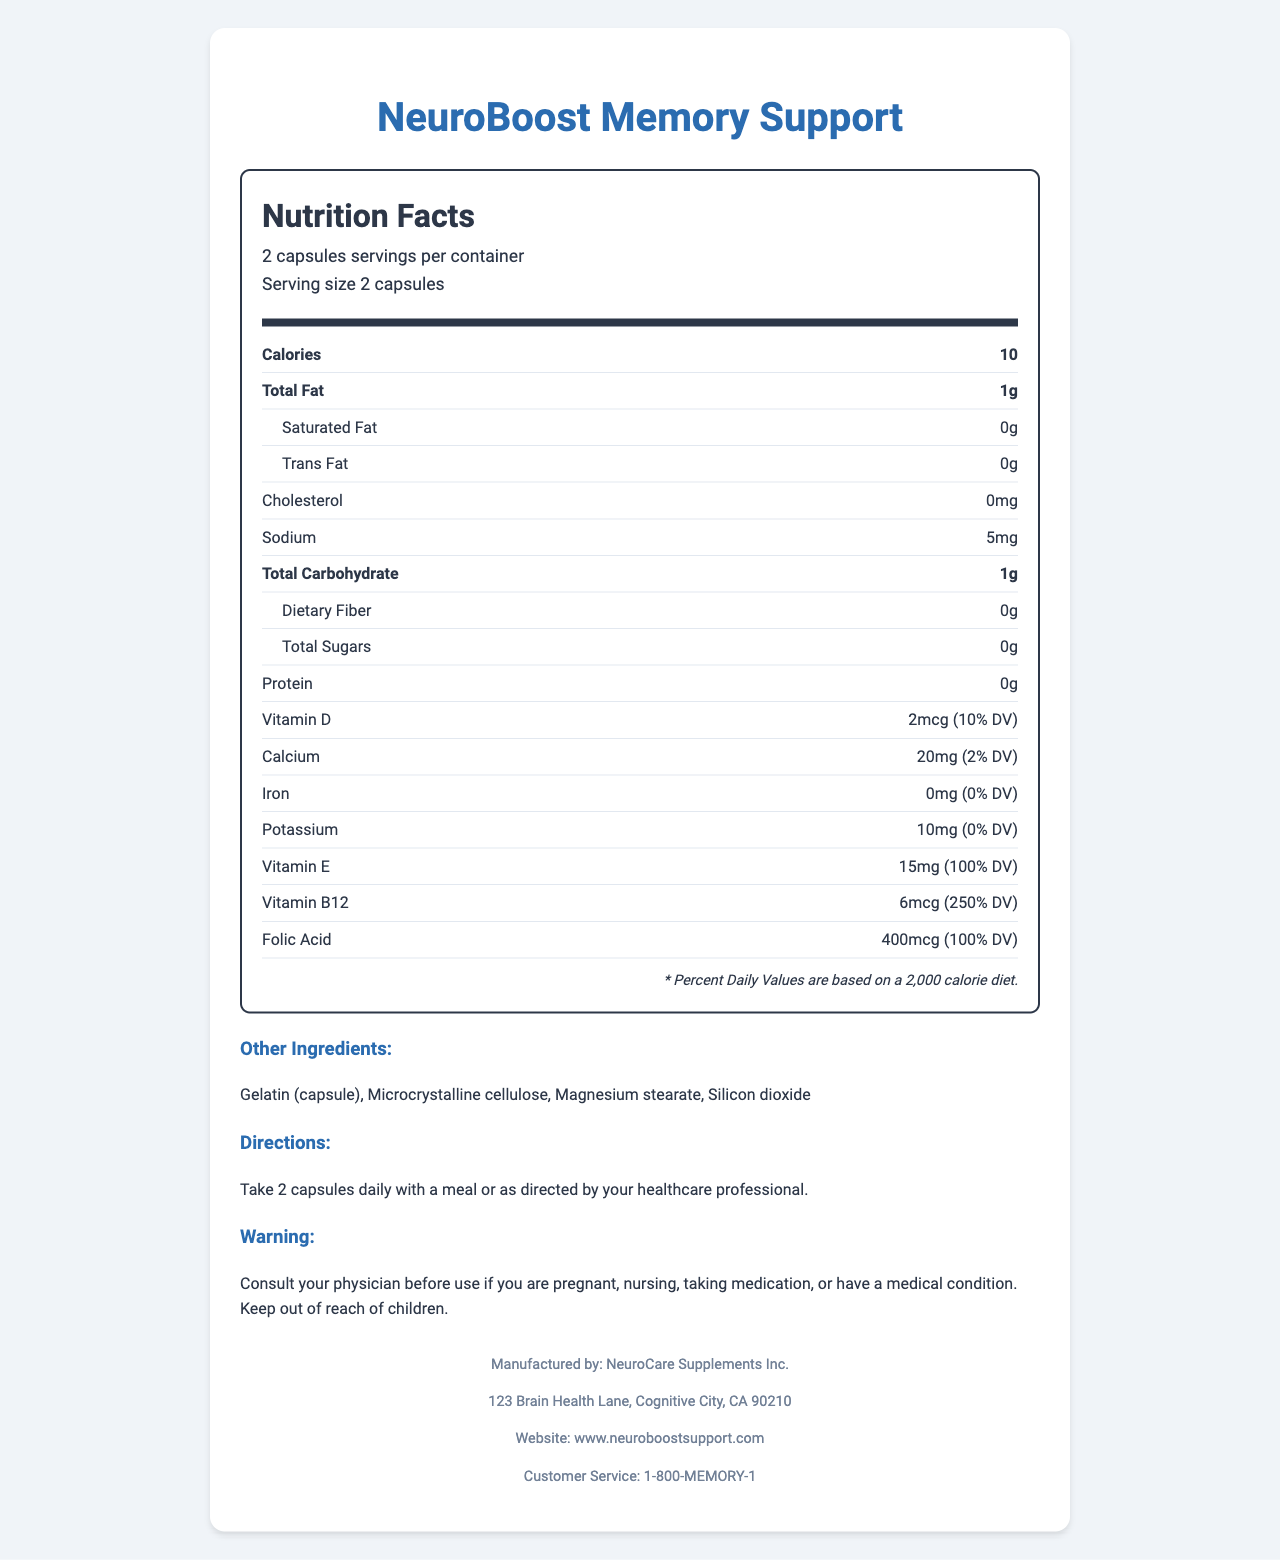what is the product's serving size? The serving size is stated at the top of the nutrition facts: "Serving size 2 capsules."
Answer: 2 capsules how many servings per container are there? The document specifies that there are 30 servings per container.
Answer: 30 what is the total amount of omega-3 fatty acids per serving? The document lists that each serving contains 1000mg of omega-3 fatty acids.
Answer: 1000mg which vitamin has the highest daily value percentage? The daily value for Vitamin B12 is listed as 250%, which is higher than any other vitamin listed.
Answer: Vitamin B12 what are the potential allergens in this supplement? The allergen information states that the product contains fish ingredients.
Answer: Fish (anchovy, sardine) which nutrient contributes the most to the daily value percentage? A. Vitamin D B. Vitamin E C. Vitamin B12 D. Folic Acid Vitamin B12 has a daily value of 250%, while the other options have lower percentages.
Answer: C how much acetyl L-carnitine is in each serving? A. 50mg B. 100mg C. 500mg D. 1000mg The document states there is 500mg of acetyl L-carnitine per serving.
Answer: C is there any cholesterol in this supplement? The document shows 0mg of cholesterol per serving.
Answer: No is the main function of the supplement to support memory? The product name "NeuroBoost Memory Support" indicates its main function is to support memory.
Answer: Yes please summarize the key information provided in the document. The document details the nutritional contents, directions for use, warnings, and manufacturer information for "NeuroBoost Memory Support."
Answer: The supplement "NeuroBoost Memory Support," manufactured by NeuroCare Supplements Inc., provides various nutrients designed to support memory with significant doses of omega-3 fatty acids and several vitamins and minerals. Each serving size is 2 capsules, with 30 servings per container. Key ingredients include EPA, DHA, phosphatidylserine, and ginkgo biloba extract. In addition to containing fish ingredients, the product provides specific directions for use, storage, and warnings for certain groups. what is the amount of sodium per serving? The amount of sodium per serving is listed as 5mg.
Answer: 5mg how much total fat is in one serving? Each serving contains 1g of total fat, as specified in the nutrition facts.
Answer: 1g list some of the other ingredients in this supplement. The other ingredients are listed in the ingredients section.
Answer: Gelatin (capsule), Microcrystalline cellulose, Magnesium stearate, Silicon dioxide which mineral has the lowest daily value percentage? Potassium has a daily value percentage of 0%, which is the lowest compared to other listed minerals.
Answer: Potassium what is the manufacturer’s customer service phone number? The customer service phone number provided in the manufacturer info is 1-800-MEMORY-1.
Answer: 1-800-MEMORY-1 can this supplement be used by pregnant women without consulting a physician? The warning section advises consulting a physician before use if you are pregnant.
Answer: No does the supplement provide any iron? The document lists 0mg of iron per serving.
Answer: No how many calories are there in a single serving size of the supplement? The number of calories per serving size is listed as 10.
Answer: 10 what is the address of the manufacturer? The address is listed under the manufacturer information section.
Answer: 123 Brain Health Lane, Cognitive City, CA 90210 what is the specific amount of EPA in the omega-3 content? EPA content in the omega-3 fatty acids is listed as 300mg.
Answer: 300mg is there any information on the manufacturing date of this product? The document does not provide any information on the manufacturing date.
Answer: Cannot be determined 